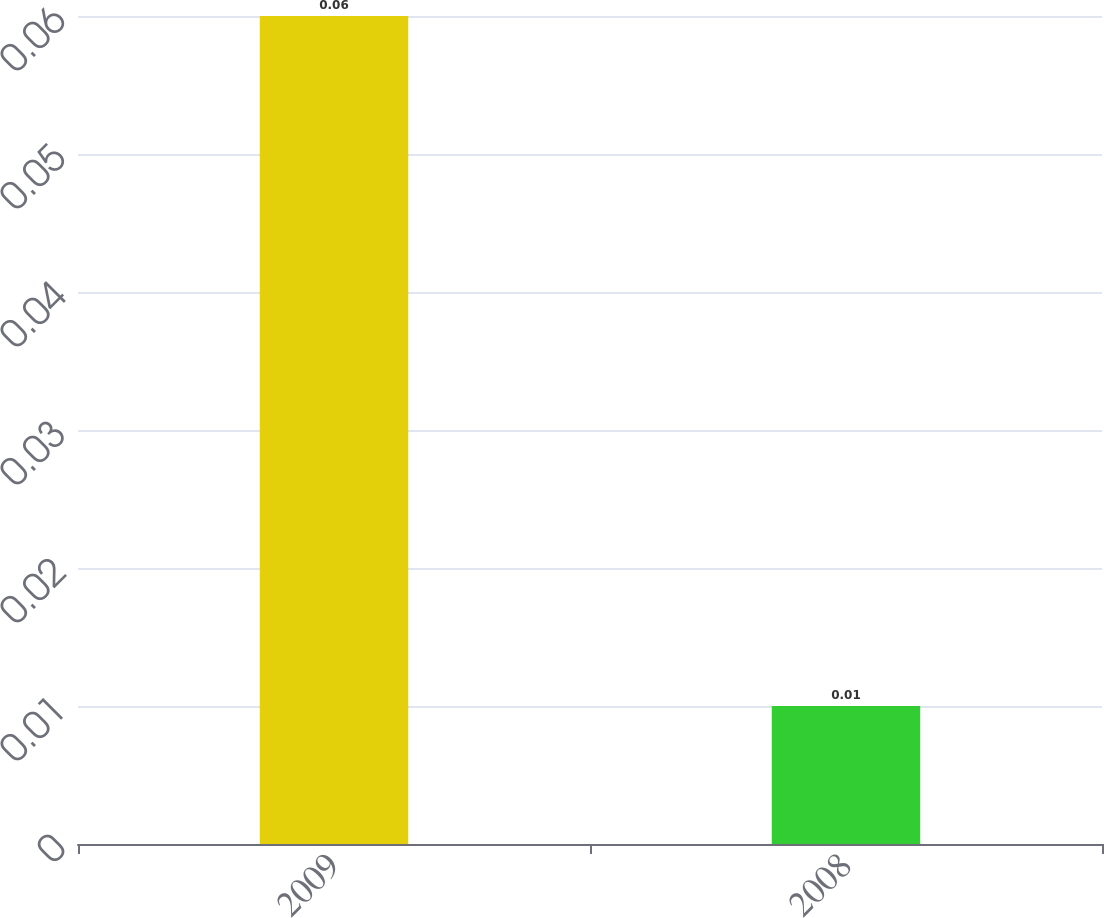Convert chart. <chart><loc_0><loc_0><loc_500><loc_500><bar_chart><fcel>2009<fcel>2008<nl><fcel>0.06<fcel>0.01<nl></chart> 